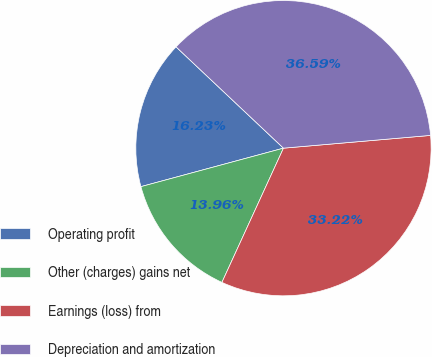Convert chart. <chart><loc_0><loc_0><loc_500><loc_500><pie_chart><fcel>Operating profit<fcel>Other (charges) gains net<fcel>Earnings (loss) from<fcel>Depreciation and amortization<nl><fcel>16.23%<fcel>13.96%<fcel>33.22%<fcel>36.59%<nl></chart> 